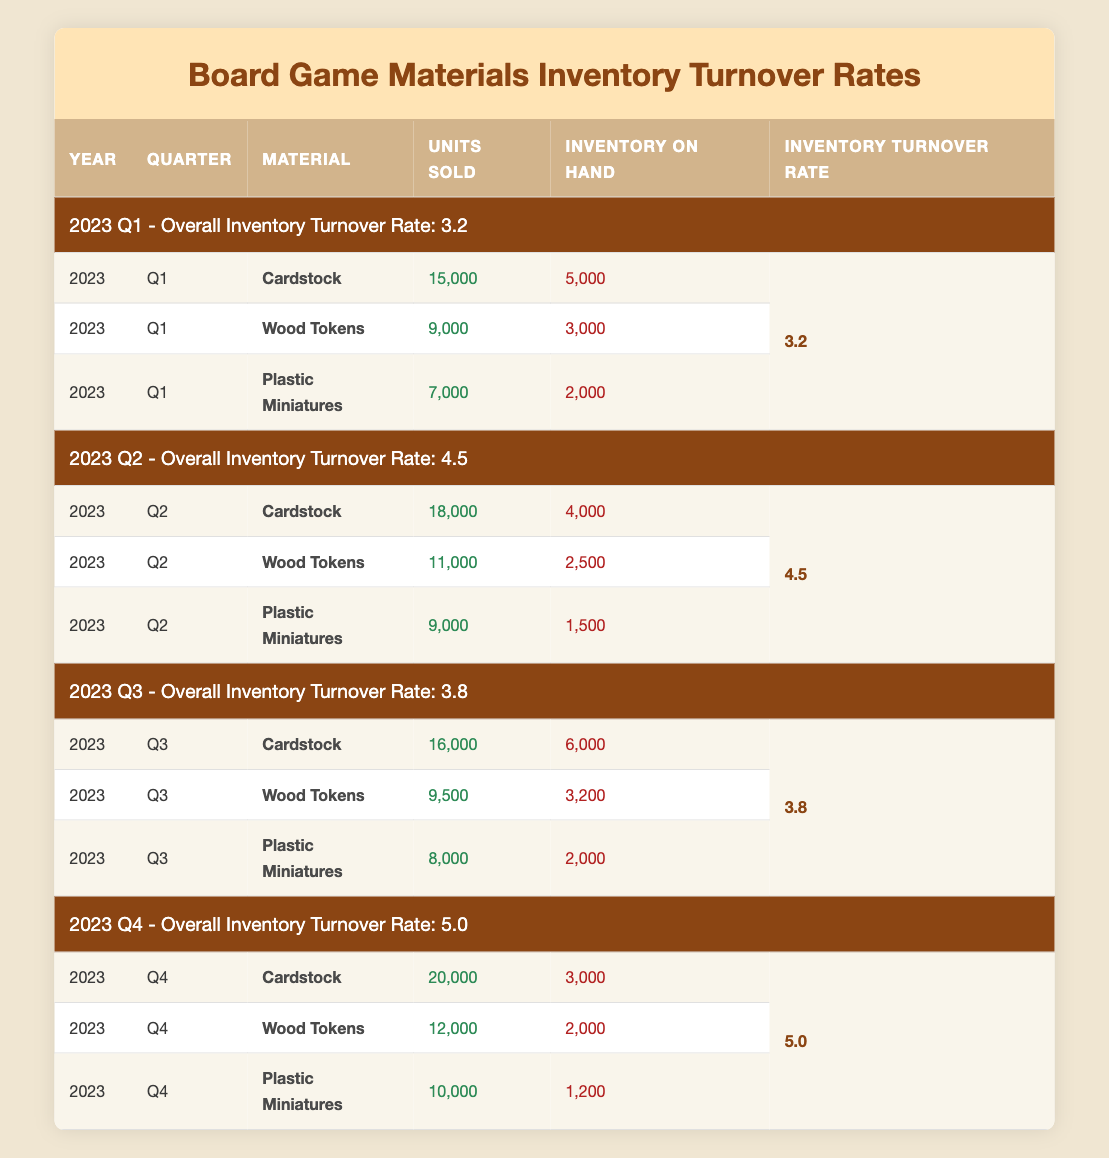What is the Inventory Turnover Rate for Q2 of 2023? The table shows that for Q2 of 2023, the Inventory Turnover Rate is listed as 4.5.
Answer: 4.5 Which quarter had the highest Inventory Turnover Rate? By comparing the Inventory Turnover Rates in each quarter, Q4 of 2023 has the highest rate at 5.0.
Answer: Q4 of 2023 What is the total number of units sold for Cardstock in 2023? The total for Cardstock can be calculated by summing the units sold across all four quarters: 15,000 + 18,000 + 16,000 + 20,000 = 69,000.
Answer: 69,000 Are more Plastic Miniatures sold in Q2 than in Q1? In Q2, 9,000 Plastic Miniatures were sold, which is more than the 7,000 sold in Q1. Thus, the statement is true.
Answer: Yes What is the difference in Units Sold for Wood Tokens between Q3 and Q4? The Units Sold for Wood Tokens in Q3 is 9,500 and in Q4 is 12,000. The difference is calculated as 12,000 - 9,500 = 2,500.
Answer: 2,500 How many units of Plastic Miniatures are on hand in Q3? The table indicates that in Q3, there are 2,000 units of Plastic Miniatures on hand.
Answer: 2,000 In which quarter were the least number of units of Cardstock sold? By reviewing the units sold per quarter for Cardstock: Q1 (15,000), Q2 (18,000), Q3 (16,000), and Q4 (20,000), it's evident that Q1 has the least at 15,000 units.
Answer: Q1 What is the average Inventory Turnover Rate across all four quarters? The Inventory Turnover Rates for the four quarters are 3.2, 4.5, 3.8, and 5.0. To find the average, we sum these (3.2 + 4.5 + 3.8 + 5.0 = 16.5) and divide by 4, giving an average of 4.125.
Answer: 4.125 Is the Inventory on Hand for Cardstock greater in Q1 or Q2? The Inventory on Hand for Cardstock is 5,000 in Q1 and 4,000 in Q2; since 5,000 is greater than 4,000, the answer is Q1.
Answer: Q1 